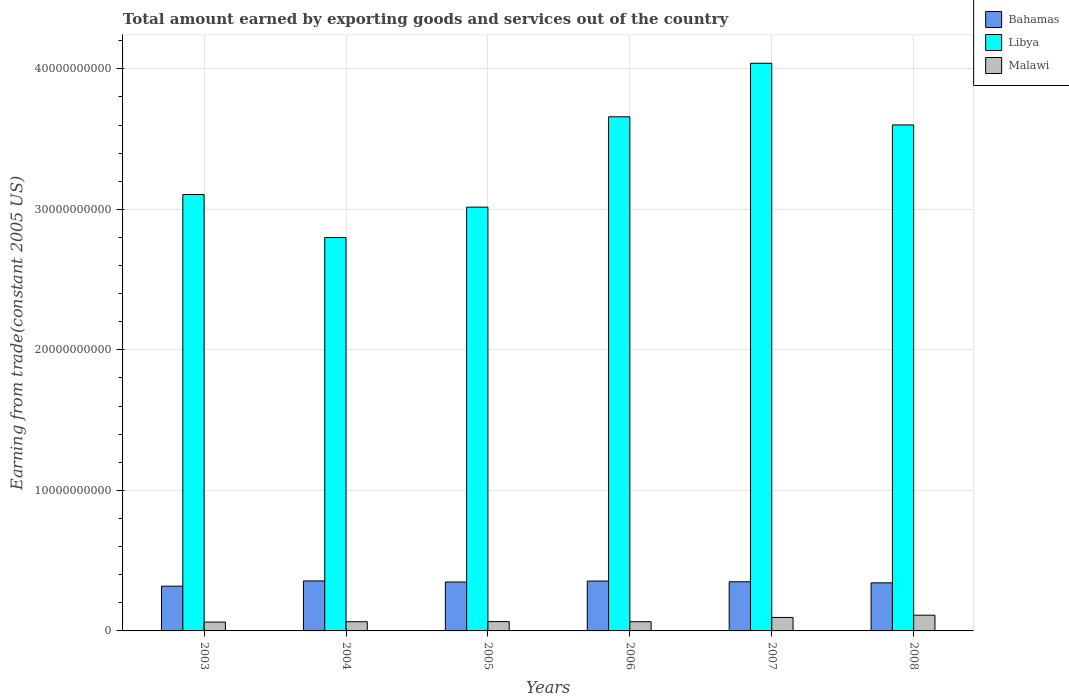Are the number of bars on each tick of the X-axis equal?
Your response must be concise. Yes. In how many cases, is the number of bars for a given year not equal to the number of legend labels?
Your answer should be compact. 0. What is the total amount earned by exporting goods and services in Bahamas in 2007?
Your answer should be very brief. 3.50e+09. Across all years, what is the maximum total amount earned by exporting goods and services in Malawi?
Ensure brevity in your answer.  1.12e+09. Across all years, what is the minimum total amount earned by exporting goods and services in Bahamas?
Your answer should be compact. 3.19e+09. What is the total total amount earned by exporting goods and services in Bahamas in the graph?
Your response must be concise. 2.07e+1. What is the difference between the total amount earned by exporting goods and services in Bahamas in 2003 and that in 2006?
Offer a very short reply. -3.64e+08. What is the difference between the total amount earned by exporting goods and services in Malawi in 2008 and the total amount earned by exporting goods and services in Bahamas in 2004?
Your response must be concise. -2.44e+09. What is the average total amount earned by exporting goods and services in Bahamas per year?
Your answer should be compact. 3.45e+09. In the year 2008, what is the difference between the total amount earned by exporting goods and services in Malawi and total amount earned by exporting goods and services in Bahamas?
Ensure brevity in your answer.  -2.30e+09. In how many years, is the total amount earned by exporting goods and services in Libya greater than 12000000000 US$?
Your answer should be very brief. 6. What is the ratio of the total amount earned by exporting goods and services in Libya in 2006 to that in 2008?
Offer a very short reply. 1.02. Is the difference between the total amount earned by exporting goods and services in Malawi in 2005 and 2006 greater than the difference between the total amount earned by exporting goods and services in Bahamas in 2005 and 2006?
Your answer should be very brief. Yes. What is the difference between the highest and the second highest total amount earned by exporting goods and services in Malawi?
Provide a succinct answer. 1.60e+08. What is the difference between the highest and the lowest total amount earned by exporting goods and services in Malawi?
Make the answer very short. 4.91e+08. In how many years, is the total amount earned by exporting goods and services in Malawi greater than the average total amount earned by exporting goods and services in Malawi taken over all years?
Keep it short and to the point. 2. What does the 3rd bar from the left in 2003 represents?
Make the answer very short. Malawi. What does the 2nd bar from the right in 2006 represents?
Keep it short and to the point. Libya. How many bars are there?
Your response must be concise. 18. Are all the bars in the graph horizontal?
Your answer should be very brief. No. What is the difference between two consecutive major ticks on the Y-axis?
Your answer should be compact. 1.00e+1. Are the values on the major ticks of Y-axis written in scientific E-notation?
Give a very brief answer. No. Does the graph contain any zero values?
Provide a succinct answer. No. How many legend labels are there?
Your answer should be compact. 3. How are the legend labels stacked?
Make the answer very short. Vertical. What is the title of the graph?
Provide a succinct answer. Total amount earned by exporting goods and services out of the country. What is the label or title of the X-axis?
Provide a short and direct response. Years. What is the label or title of the Y-axis?
Give a very brief answer. Earning from trade(constant 2005 US). What is the Earning from trade(constant 2005 US) in Bahamas in 2003?
Your response must be concise. 3.19e+09. What is the Earning from trade(constant 2005 US) in Libya in 2003?
Your answer should be compact. 3.11e+1. What is the Earning from trade(constant 2005 US) of Malawi in 2003?
Offer a very short reply. 6.29e+08. What is the Earning from trade(constant 2005 US) of Bahamas in 2004?
Your answer should be compact. 3.56e+09. What is the Earning from trade(constant 2005 US) of Libya in 2004?
Keep it short and to the point. 2.80e+1. What is the Earning from trade(constant 2005 US) of Malawi in 2004?
Provide a short and direct response. 6.55e+08. What is the Earning from trade(constant 2005 US) in Bahamas in 2005?
Offer a very short reply. 3.48e+09. What is the Earning from trade(constant 2005 US) in Libya in 2005?
Your answer should be very brief. 3.02e+1. What is the Earning from trade(constant 2005 US) in Malawi in 2005?
Give a very brief answer. 6.62e+08. What is the Earning from trade(constant 2005 US) of Bahamas in 2006?
Ensure brevity in your answer.  3.55e+09. What is the Earning from trade(constant 2005 US) of Libya in 2006?
Offer a very short reply. 3.66e+1. What is the Earning from trade(constant 2005 US) in Malawi in 2006?
Ensure brevity in your answer.  6.55e+08. What is the Earning from trade(constant 2005 US) of Bahamas in 2007?
Offer a very short reply. 3.50e+09. What is the Earning from trade(constant 2005 US) of Libya in 2007?
Your response must be concise. 4.04e+1. What is the Earning from trade(constant 2005 US) in Malawi in 2007?
Your answer should be very brief. 9.60e+08. What is the Earning from trade(constant 2005 US) of Bahamas in 2008?
Offer a terse response. 3.42e+09. What is the Earning from trade(constant 2005 US) in Libya in 2008?
Make the answer very short. 3.60e+1. What is the Earning from trade(constant 2005 US) of Malawi in 2008?
Provide a short and direct response. 1.12e+09. Across all years, what is the maximum Earning from trade(constant 2005 US) in Bahamas?
Offer a terse response. 3.56e+09. Across all years, what is the maximum Earning from trade(constant 2005 US) of Libya?
Offer a terse response. 4.04e+1. Across all years, what is the maximum Earning from trade(constant 2005 US) of Malawi?
Ensure brevity in your answer.  1.12e+09. Across all years, what is the minimum Earning from trade(constant 2005 US) in Bahamas?
Provide a succinct answer. 3.19e+09. Across all years, what is the minimum Earning from trade(constant 2005 US) of Libya?
Provide a succinct answer. 2.80e+1. Across all years, what is the minimum Earning from trade(constant 2005 US) in Malawi?
Make the answer very short. 6.29e+08. What is the total Earning from trade(constant 2005 US) in Bahamas in the graph?
Ensure brevity in your answer.  2.07e+1. What is the total Earning from trade(constant 2005 US) of Libya in the graph?
Provide a short and direct response. 2.02e+11. What is the total Earning from trade(constant 2005 US) in Malawi in the graph?
Offer a very short reply. 4.68e+09. What is the difference between the Earning from trade(constant 2005 US) in Bahamas in 2003 and that in 2004?
Provide a short and direct response. -3.73e+08. What is the difference between the Earning from trade(constant 2005 US) in Libya in 2003 and that in 2004?
Your answer should be very brief. 3.07e+09. What is the difference between the Earning from trade(constant 2005 US) of Malawi in 2003 and that in 2004?
Ensure brevity in your answer.  -2.59e+07. What is the difference between the Earning from trade(constant 2005 US) in Bahamas in 2003 and that in 2005?
Provide a succinct answer. -2.96e+08. What is the difference between the Earning from trade(constant 2005 US) of Libya in 2003 and that in 2005?
Make the answer very short. 9.00e+08. What is the difference between the Earning from trade(constant 2005 US) in Malawi in 2003 and that in 2005?
Your answer should be compact. -3.39e+07. What is the difference between the Earning from trade(constant 2005 US) in Bahamas in 2003 and that in 2006?
Provide a short and direct response. -3.64e+08. What is the difference between the Earning from trade(constant 2005 US) of Libya in 2003 and that in 2006?
Your answer should be very brief. -5.53e+09. What is the difference between the Earning from trade(constant 2005 US) of Malawi in 2003 and that in 2006?
Offer a very short reply. -2.64e+07. What is the difference between the Earning from trade(constant 2005 US) in Bahamas in 2003 and that in 2007?
Your answer should be very brief. -3.14e+08. What is the difference between the Earning from trade(constant 2005 US) of Libya in 2003 and that in 2007?
Offer a very short reply. -9.34e+09. What is the difference between the Earning from trade(constant 2005 US) in Malawi in 2003 and that in 2007?
Provide a succinct answer. -3.31e+08. What is the difference between the Earning from trade(constant 2005 US) of Bahamas in 2003 and that in 2008?
Offer a terse response. -2.37e+08. What is the difference between the Earning from trade(constant 2005 US) in Libya in 2003 and that in 2008?
Give a very brief answer. -4.95e+09. What is the difference between the Earning from trade(constant 2005 US) of Malawi in 2003 and that in 2008?
Provide a short and direct response. -4.91e+08. What is the difference between the Earning from trade(constant 2005 US) of Bahamas in 2004 and that in 2005?
Offer a very short reply. 7.62e+07. What is the difference between the Earning from trade(constant 2005 US) in Libya in 2004 and that in 2005?
Offer a terse response. -2.16e+09. What is the difference between the Earning from trade(constant 2005 US) of Malawi in 2004 and that in 2005?
Offer a very short reply. -7.98e+06. What is the difference between the Earning from trade(constant 2005 US) of Bahamas in 2004 and that in 2006?
Provide a succinct answer. 8.46e+06. What is the difference between the Earning from trade(constant 2005 US) of Libya in 2004 and that in 2006?
Your answer should be very brief. -8.59e+09. What is the difference between the Earning from trade(constant 2005 US) of Malawi in 2004 and that in 2006?
Make the answer very short. -5.11e+05. What is the difference between the Earning from trade(constant 2005 US) in Bahamas in 2004 and that in 2007?
Give a very brief answer. 5.91e+07. What is the difference between the Earning from trade(constant 2005 US) of Libya in 2004 and that in 2007?
Your answer should be very brief. -1.24e+1. What is the difference between the Earning from trade(constant 2005 US) in Malawi in 2004 and that in 2007?
Keep it short and to the point. -3.05e+08. What is the difference between the Earning from trade(constant 2005 US) of Bahamas in 2004 and that in 2008?
Provide a succinct answer. 1.36e+08. What is the difference between the Earning from trade(constant 2005 US) in Libya in 2004 and that in 2008?
Ensure brevity in your answer.  -8.02e+09. What is the difference between the Earning from trade(constant 2005 US) of Malawi in 2004 and that in 2008?
Provide a succinct answer. -4.66e+08. What is the difference between the Earning from trade(constant 2005 US) in Bahamas in 2005 and that in 2006?
Ensure brevity in your answer.  -6.77e+07. What is the difference between the Earning from trade(constant 2005 US) of Libya in 2005 and that in 2006?
Provide a short and direct response. -6.43e+09. What is the difference between the Earning from trade(constant 2005 US) of Malawi in 2005 and that in 2006?
Provide a short and direct response. 7.47e+06. What is the difference between the Earning from trade(constant 2005 US) in Bahamas in 2005 and that in 2007?
Offer a terse response. -1.71e+07. What is the difference between the Earning from trade(constant 2005 US) of Libya in 2005 and that in 2007?
Give a very brief answer. -1.02e+1. What is the difference between the Earning from trade(constant 2005 US) of Malawi in 2005 and that in 2007?
Offer a very short reply. -2.97e+08. What is the difference between the Earning from trade(constant 2005 US) of Bahamas in 2005 and that in 2008?
Provide a succinct answer. 5.99e+07. What is the difference between the Earning from trade(constant 2005 US) in Libya in 2005 and that in 2008?
Give a very brief answer. -5.85e+09. What is the difference between the Earning from trade(constant 2005 US) in Malawi in 2005 and that in 2008?
Provide a succinct answer. -4.58e+08. What is the difference between the Earning from trade(constant 2005 US) in Bahamas in 2006 and that in 2007?
Keep it short and to the point. 5.06e+07. What is the difference between the Earning from trade(constant 2005 US) in Libya in 2006 and that in 2007?
Make the answer very short. -3.81e+09. What is the difference between the Earning from trade(constant 2005 US) in Malawi in 2006 and that in 2007?
Your answer should be compact. -3.05e+08. What is the difference between the Earning from trade(constant 2005 US) of Bahamas in 2006 and that in 2008?
Your answer should be very brief. 1.28e+08. What is the difference between the Earning from trade(constant 2005 US) of Libya in 2006 and that in 2008?
Make the answer very short. 5.77e+08. What is the difference between the Earning from trade(constant 2005 US) in Malawi in 2006 and that in 2008?
Ensure brevity in your answer.  -4.65e+08. What is the difference between the Earning from trade(constant 2005 US) of Bahamas in 2007 and that in 2008?
Give a very brief answer. 7.70e+07. What is the difference between the Earning from trade(constant 2005 US) of Libya in 2007 and that in 2008?
Provide a short and direct response. 4.39e+09. What is the difference between the Earning from trade(constant 2005 US) of Malawi in 2007 and that in 2008?
Your answer should be very brief. -1.60e+08. What is the difference between the Earning from trade(constant 2005 US) in Bahamas in 2003 and the Earning from trade(constant 2005 US) in Libya in 2004?
Your response must be concise. -2.48e+1. What is the difference between the Earning from trade(constant 2005 US) in Bahamas in 2003 and the Earning from trade(constant 2005 US) in Malawi in 2004?
Give a very brief answer. 2.53e+09. What is the difference between the Earning from trade(constant 2005 US) of Libya in 2003 and the Earning from trade(constant 2005 US) of Malawi in 2004?
Provide a short and direct response. 3.04e+1. What is the difference between the Earning from trade(constant 2005 US) of Bahamas in 2003 and the Earning from trade(constant 2005 US) of Libya in 2005?
Your answer should be very brief. -2.70e+1. What is the difference between the Earning from trade(constant 2005 US) of Bahamas in 2003 and the Earning from trade(constant 2005 US) of Malawi in 2005?
Ensure brevity in your answer.  2.52e+09. What is the difference between the Earning from trade(constant 2005 US) of Libya in 2003 and the Earning from trade(constant 2005 US) of Malawi in 2005?
Provide a succinct answer. 3.04e+1. What is the difference between the Earning from trade(constant 2005 US) of Bahamas in 2003 and the Earning from trade(constant 2005 US) of Libya in 2006?
Offer a very short reply. -3.34e+1. What is the difference between the Earning from trade(constant 2005 US) of Bahamas in 2003 and the Earning from trade(constant 2005 US) of Malawi in 2006?
Offer a terse response. 2.53e+09. What is the difference between the Earning from trade(constant 2005 US) of Libya in 2003 and the Earning from trade(constant 2005 US) of Malawi in 2006?
Your response must be concise. 3.04e+1. What is the difference between the Earning from trade(constant 2005 US) in Bahamas in 2003 and the Earning from trade(constant 2005 US) in Libya in 2007?
Ensure brevity in your answer.  -3.72e+1. What is the difference between the Earning from trade(constant 2005 US) in Bahamas in 2003 and the Earning from trade(constant 2005 US) in Malawi in 2007?
Keep it short and to the point. 2.23e+09. What is the difference between the Earning from trade(constant 2005 US) of Libya in 2003 and the Earning from trade(constant 2005 US) of Malawi in 2007?
Ensure brevity in your answer.  3.01e+1. What is the difference between the Earning from trade(constant 2005 US) of Bahamas in 2003 and the Earning from trade(constant 2005 US) of Libya in 2008?
Make the answer very short. -3.28e+1. What is the difference between the Earning from trade(constant 2005 US) in Bahamas in 2003 and the Earning from trade(constant 2005 US) in Malawi in 2008?
Offer a terse response. 2.07e+09. What is the difference between the Earning from trade(constant 2005 US) in Libya in 2003 and the Earning from trade(constant 2005 US) in Malawi in 2008?
Give a very brief answer. 2.99e+1. What is the difference between the Earning from trade(constant 2005 US) of Bahamas in 2004 and the Earning from trade(constant 2005 US) of Libya in 2005?
Your response must be concise. -2.66e+1. What is the difference between the Earning from trade(constant 2005 US) of Bahamas in 2004 and the Earning from trade(constant 2005 US) of Malawi in 2005?
Your answer should be very brief. 2.90e+09. What is the difference between the Earning from trade(constant 2005 US) in Libya in 2004 and the Earning from trade(constant 2005 US) in Malawi in 2005?
Offer a terse response. 2.73e+1. What is the difference between the Earning from trade(constant 2005 US) of Bahamas in 2004 and the Earning from trade(constant 2005 US) of Libya in 2006?
Provide a short and direct response. -3.30e+1. What is the difference between the Earning from trade(constant 2005 US) in Bahamas in 2004 and the Earning from trade(constant 2005 US) in Malawi in 2006?
Your response must be concise. 2.90e+09. What is the difference between the Earning from trade(constant 2005 US) in Libya in 2004 and the Earning from trade(constant 2005 US) in Malawi in 2006?
Provide a short and direct response. 2.73e+1. What is the difference between the Earning from trade(constant 2005 US) in Bahamas in 2004 and the Earning from trade(constant 2005 US) in Libya in 2007?
Keep it short and to the point. -3.68e+1. What is the difference between the Earning from trade(constant 2005 US) of Bahamas in 2004 and the Earning from trade(constant 2005 US) of Malawi in 2007?
Your answer should be very brief. 2.60e+09. What is the difference between the Earning from trade(constant 2005 US) in Libya in 2004 and the Earning from trade(constant 2005 US) in Malawi in 2007?
Keep it short and to the point. 2.70e+1. What is the difference between the Earning from trade(constant 2005 US) of Bahamas in 2004 and the Earning from trade(constant 2005 US) of Libya in 2008?
Keep it short and to the point. -3.25e+1. What is the difference between the Earning from trade(constant 2005 US) of Bahamas in 2004 and the Earning from trade(constant 2005 US) of Malawi in 2008?
Give a very brief answer. 2.44e+09. What is the difference between the Earning from trade(constant 2005 US) in Libya in 2004 and the Earning from trade(constant 2005 US) in Malawi in 2008?
Provide a succinct answer. 2.69e+1. What is the difference between the Earning from trade(constant 2005 US) in Bahamas in 2005 and the Earning from trade(constant 2005 US) in Libya in 2006?
Keep it short and to the point. -3.31e+1. What is the difference between the Earning from trade(constant 2005 US) of Bahamas in 2005 and the Earning from trade(constant 2005 US) of Malawi in 2006?
Provide a short and direct response. 2.83e+09. What is the difference between the Earning from trade(constant 2005 US) of Libya in 2005 and the Earning from trade(constant 2005 US) of Malawi in 2006?
Give a very brief answer. 2.95e+1. What is the difference between the Earning from trade(constant 2005 US) in Bahamas in 2005 and the Earning from trade(constant 2005 US) in Libya in 2007?
Your response must be concise. -3.69e+1. What is the difference between the Earning from trade(constant 2005 US) in Bahamas in 2005 and the Earning from trade(constant 2005 US) in Malawi in 2007?
Your answer should be compact. 2.52e+09. What is the difference between the Earning from trade(constant 2005 US) of Libya in 2005 and the Earning from trade(constant 2005 US) of Malawi in 2007?
Your response must be concise. 2.92e+1. What is the difference between the Earning from trade(constant 2005 US) in Bahamas in 2005 and the Earning from trade(constant 2005 US) in Libya in 2008?
Give a very brief answer. -3.25e+1. What is the difference between the Earning from trade(constant 2005 US) of Bahamas in 2005 and the Earning from trade(constant 2005 US) of Malawi in 2008?
Provide a short and direct response. 2.36e+09. What is the difference between the Earning from trade(constant 2005 US) in Libya in 2005 and the Earning from trade(constant 2005 US) in Malawi in 2008?
Offer a very short reply. 2.90e+1. What is the difference between the Earning from trade(constant 2005 US) in Bahamas in 2006 and the Earning from trade(constant 2005 US) in Libya in 2007?
Ensure brevity in your answer.  -3.68e+1. What is the difference between the Earning from trade(constant 2005 US) in Bahamas in 2006 and the Earning from trade(constant 2005 US) in Malawi in 2007?
Make the answer very short. 2.59e+09. What is the difference between the Earning from trade(constant 2005 US) in Libya in 2006 and the Earning from trade(constant 2005 US) in Malawi in 2007?
Give a very brief answer. 3.56e+1. What is the difference between the Earning from trade(constant 2005 US) in Bahamas in 2006 and the Earning from trade(constant 2005 US) in Libya in 2008?
Offer a terse response. -3.25e+1. What is the difference between the Earning from trade(constant 2005 US) of Bahamas in 2006 and the Earning from trade(constant 2005 US) of Malawi in 2008?
Your answer should be compact. 2.43e+09. What is the difference between the Earning from trade(constant 2005 US) of Libya in 2006 and the Earning from trade(constant 2005 US) of Malawi in 2008?
Offer a terse response. 3.55e+1. What is the difference between the Earning from trade(constant 2005 US) of Bahamas in 2007 and the Earning from trade(constant 2005 US) of Libya in 2008?
Your answer should be compact. -3.25e+1. What is the difference between the Earning from trade(constant 2005 US) of Bahamas in 2007 and the Earning from trade(constant 2005 US) of Malawi in 2008?
Provide a succinct answer. 2.38e+09. What is the difference between the Earning from trade(constant 2005 US) of Libya in 2007 and the Earning from trade(constant 2005 US) of Malawi in 2008?
Ensure brevity in your answer.  3.93e+1. What is the average Earning from trade(constant 2005 US) in Bahamas per year?
Provide a short and direct response. 3.45e+09. What is the average Earning from trade(constant 2005 US) of Libya per year?
Ensure brevity in your answer.  3.37e+1. What is the average Earning from trade(constant 2005 US) of Malawi per year?
Your answer should be compact. 7.80e+08. In the year 2003, what is the difference between the Earning from trade(constant 2005 US) in Bahamas and Earning from trade(constant 2005 US) in Libya?
Keep it short and to the point. -2.79e+1. In the year 2003, what is the difference between the Earning from trade(constant 2005 US) of Bahamas and Earning from trade(constant 2005 US) of Malawi?
Give a very brief answer. 2.56e+09. In the year 2003, what is the difference between the Earning from trade(constant 2005 US) in Libya and Earning from trade(constant 2005 US) in Malawi?
Make the answer very short. 3.04e+1. In the year 2004, what is the difference between the Earning from trade(constant 2005 US) in Bahamas and Earning from trade(constant 2005 US) in Libya?
Provide a short and direct response. -2.44e+1. In the year 2004, what is the difference between the Earning from trade(constant 2005 US) in Bahamas and Earning from trade(constant 2005 US) in Malawi?
Your answer should be compact. 2.90e+09. In the year 2004, what is the difference between the Earning from trade(constant 2005 US) in Libya and Earning from trade(constant 2005 US) in Malawi?
Make the answer very short. 2.73e+1. In the year 2005, what is the difference between the Earning from trade(constant 2005 US) in Bahamas and Earning from trade(constant 2005 US) in Libya?
Provide a short and direct response. -2.67e+1. In the year 2005, what is the difference between the Earning from trade(constant 2005 US) in Bahamas and Earning from trade(constant 2005 US) in Malawi?
Give a very brief answer. 2.82e+09. In the year 2005, what is the difference between the Earning from trade(constant 2005 US) of Libya and Earning from trade(constant 2005 US) of Malawi?
Your answer should be compact. 2.95e+1. In the year 2006, what is the difference between the Earning from trade(constant 2005 US) in Bahamas and Earning from trade(constant 2005 US) in Libya?
Ensure brevity in your answer.  -3.30e+1. In the year 2006, what is the difference between the Earning from trade(constant 2005 US) of Bahamas and Earning from trade(constant 2005 US) of Malawi?
Your answer should be compact. 2.89e+09. In the year 2006, what is the difference between the Earning from trade(constant 2005 US) of Libya and Earning from trade(constant 2005 US) of Malawi?
Your answer should be compact. 3.59e+1. In the year 2007, what is the difference between the Earning from trade(constant 2005 US) in Bahamas and Earning from trade(constant 2005 US) in Libya?
Your answer should be very brief. -3.69e+1. In the year 2007, what is the difference between the Earning from trade(constant 2005 US) in Bahamas and Earning from trade(constant 2005 US) in Malawi?
Keep it short and to the point. 2.54e+09. In the year 2007, what is the difference between the Earning from trade(constant 2005 US) of Libya and Earning from trade(constant 2005 US) of Malawi?
Provide a succinct answer. 3.94e+1. In the year 2008, what is the difference between the Earning from trade(constant 2005 US) of Bahamas and Earning from trade(constant 2005 US) of Libya?
Your response must be concise. -3.26e+1. In the year 2008, what is the difference between the Earning from trade(constant 2005 US) in Bahamas and Earning from trade(constant 2005 US) in Malawi?
Your response must be concise. 2.30e+09. In the year 2008, what is the difference between the Earning from trade(constant 2005 US) in Libya and Earning from trade(constant 2005 US) in Malawi?
Your answer should be very brief. 3.49e+1. What is the ratio of the Earning from trade(constant 2005 US) of Bahamas in 2003 to that in 2004?
Make the answer very short. 0.9. What is the ratio of the Earning from trade(constant 2005 US) of Libya in 2003 to that in 2004?
Your answer should be very brief. 1.11. What is the ratio of the Earning from trade(constant 2005 US) in Malawi in 2003 to that in 2004?
Offer a very short reply. 0.96. What is the ratio of the Earning from trade(constant 2005 US) of Bahamas in 2003 to that in 2005?
Make the answer very short. 0.91. What is the ratio of the Earning from trade(constant 2005 US) in Libya in 2003 to that in 2005?
Keep it short and to the point. 1.03. What is the ratio of the Earning from trade(constant 2005 US) in Malawi in 2003 to that in 2005?
Keep it short and to the point. 0.95. What is the ratio of the Earning from trade(constant 2005 US) of Bahamas in 2003 to that in 2006?
Make the answer very short. 0.9. What is the ratio of the Earning from trade(constant 2005 US) of Libya in 2003 to that in 2006?
Your response must be concise. 0.85. What is the ratio of the Earning from trade(constant 2005 US) in Malawi in 2003 to that in 2006?
Your answer should be compact. 0.96. What is the ratio of the Earning from trade(constant 2005 US) in Bahamas in 2003 to that in 2007?
Provide a succinct answer. 0.91. What is the ratio of the Earning from trade(constant 2005 US) of Libya in 2003 to that in 2007?
Give a very brief answer. 0.77. What is the ratio of the Earning from trade(constant 2005 US) in Malawi in 2003 to that in 2007?
Ensure brevity in your answer.  0.66. What is the ratio of the Earning from trade(constant 2005 US) in Bahamas in 2003 to that in 2008?
Ensure brevity in your answer.  0.93. What is the ratio of the Earning from trade(constant 2005 US) in Libya in 2003 to that in 2008?
Offer a terse response. 0.86. What is the ratio of the Earning from trade(constant 2005 US) of Malawi in 2003 to that in 2008?
Make the answer very short. 0.56. What is the ratio of the Earning from trade(constant 2005 US) of Bahamas in 2004 to that in 2005?
Offer a very short reply. 1.02. What is the ratio of the Earning from trade(constant 2005 US) in Libya in 2004 to that in 2005?
Make the answer very short. 0.93. What is the ratio of the Earning from trade(constant 2005 US) of Malawi in 2004 to that in 2005?
Your response must be concise. 0.99. What is the ratio of the Earning from trade(constant 2005 US) of Bahamas in 2004 to that in 2006?
Your answer should be compact. 1. What is the ratio of the Earning from trade(constant 2005 US) in Libya in 2004 to that in 2006?
Provide a short and direct response. 0.77. What is the ratio of the Earning from trade(constant 2005 US) in Malawi in 2004 to that in 2006?
Offer a very short reply. 1. What is the ratio of the Earning from trade(constant 2005 US) of Bahamas in 2004 to that in 2007?
Your answer should be compact. 1.02. What is the ratio of the Earning from trade(constant 2005 US) in Libya in 2004 to that in 2007?
Your response must be concise. 0.69. What is the ratio of the Earning from trade(constant 2005 US) in Malawi in 2004 to that in 2007?
Your response must be concise. 0.68. What is the ratio of the Earning from trade(constant 2005 US) in Bahamas in 2004 to that in 2008?
Provide a succinct answer. 1.04. What is the ratio of the Earning from trade(constant 2005 US) of Libya in 2004 to that in 2008?
Your response must be concise. 0.78. What is the ratio of the Earning from trade(constant 2005 US) in Malawi in 2004 to that in 2008?
Your response must be concise. 0.58. What is the ratio of the Earning from trade(constant 2005 US) in Bahamas in 2005 to that in 2006?
Give a very brief answer. 0.98. What is the ratio of the Earning from trade(constant 2005 US) of Libya in 2005 to that in 2006?
Offer a very short reply. 0.82. What is the ratio of the Earning from trade(constant 2005 US) of Malawi in 2005 to that in 2006?
Your response must be concise. 1.01. What is the ratio of the Earning from trade(constant 2005 US) of Bahamas in 2005 to that in 2007?
Provide a short and direct response. 1. What is the ratio of the Earning from trade(constant 2005 US) in Libya in 2005 to that in 2007?
Keep it short and to the point. 0.75. What is the ratio of the Earning from trade(constant 2005 US) of Malawi in 2005 to that in 2007?
Your response must be concise. 0.69. What is the ratio of the Earning from trade(constant 2005 US) of Bahamas in 2005 to that in 2008?
Offer a very short reply. 1.02. What is the ratio of the Earning from trade(constant 2005 US) of Libya in 2005 to that in 2008?
Give a very brief answer. 0.84. What is the ratio of the Earning from trade(constant 2005 US) in Malawi in 2005 to that in 2008?
Ensure brevity in your answer.  0.59. What is the ratio of the Earning from trade(constant 2005 US) of Bahamas in 2006 to that in 2007?
Offer a very short reply. 1.01. What is the ratio of the Earning from trade(constant 2005 US) of Libya in 2006 to that in 2007?
Offer a terse response. 0.91. What is the ratio of the Earning from trade(constant 2005 US) of Malawi in 2006 to that in 2007?
Your answer should be compact. 0.68. What is the ratio of the Earning from trade(constant 2005 US) of Bahamas in 2006 to that in 2008?
Keep it short and to the point. 1.04. What is the ratio of the Earning from trade(constant 2005 US) in Libya in 2006 to that in 2008?
Give a very brief answer. 1.02. What is the ratio of the Earning from trade(constant 2005 US) of Malawi in 2006 to that in 2008?
Give a very brief answer. 0.58. What is the ratio of the Earning from trade(constant 2005 US) in Bahamas in 2007 to that in 2008?
Ensure brevity in your answer.  1.02. What is the ratio of the Earning from trade(constant 2005 US) of Libya in 2007 to that in 2008?
Your answer should be compact. 1.12. What is the ratio of the Earning from trade(constant 2005 US) of Malawi in 2007 to that in 2008?
Offer a terse response. 0.86. What is the difference between the highest and the second highest Earning from trade(constant 2005 US) of Bahamas?
Offer a very short reply. 8.46e+06. What is the difference between the highest and the second highest Earning from trade(constant 2005 US) of Libya?
Offer a terse response. 3.81e+09. What is the difference between the highest and the second highest Earning from trade(constant 2005 US) of Malawi?
Your answer should be compact. 1.60e+08. What is the difference between the highest and the lowest Earning from trade(constant 2005 US) of Bahamas?
Your answer should be compact. 3.73e+08. What is the difference between the highest and the lowest Earning from trade(constant 2005 US) in Libya?
Keep it short and to the point. 1.24e+1. What is the difference between the highest and the lowest Earning from trade(constant 2005 US) in Malawi?
Provide a short and direct response. 4.91e+08. 